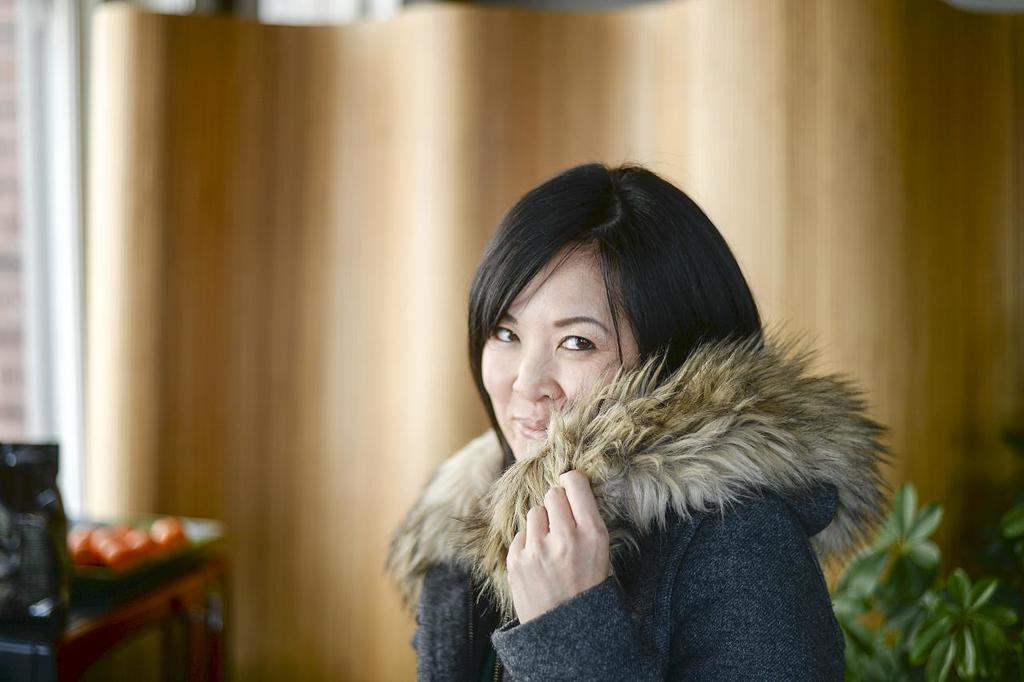Who is present in the image? There is a woman in the image. What is the woman's expression? The woman is smiling. What can be seen behind the woman? There is a plant behind the woman. What type of window treatment is visible in the image? There are curtains in the image. Where is the table located in the image? There is a table on the left side of the image. What is on top of the table? There are objects on top of the table. What type of cave can be seen in the background of the image? There is no cave present in the image; it features a woman, a plant, curtains, a table, and objects on top of the table. How many forks are visible on the table in the image? The provided facts do not mention the number or type of objects on the table, so it cannot be determined from the image. 